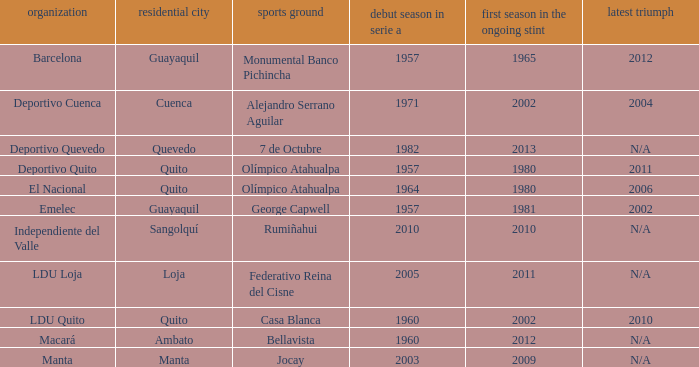Name the most for first season in the serie a for 7 de octubre 1982.0. 